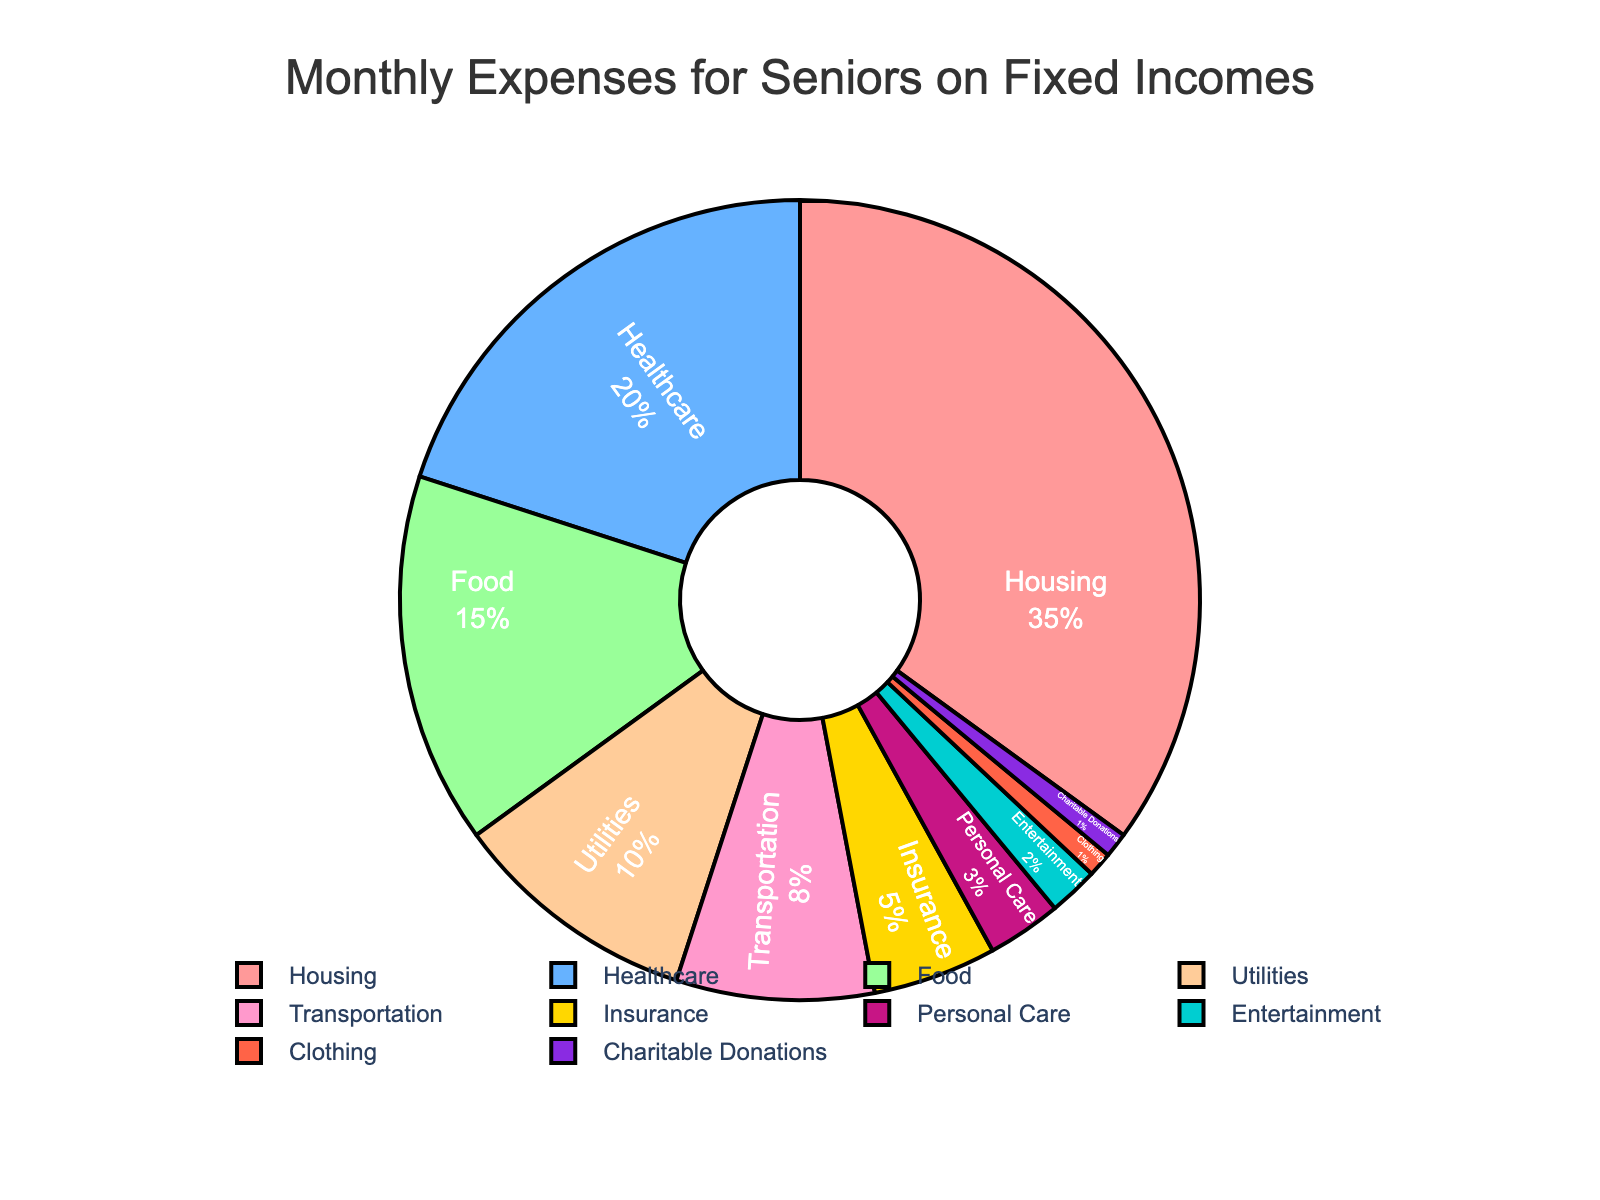Which category has the highest percentage allocation for monthly expenses? According to the pie chart, Housing has the largest slice, which indicates that it has the highest percentage allocation.
Answer: Housing What percentage of monthly expenses is spent on Healthcare and Transportation combined? The pie chart shows that Healthcare accounts for 20% and Transportation accounts for 8% of the monthly expenses. Adding these two gives 20% + 8% = 28%.
Answer: 28% Is the allocation for Food greater than for Utilities? Referring to the pie chart, Food accounts for 15% of expenses whereas Utilities account for 10%. Therefore, the allocation for Food is greater.
Answer: Yes How does the allocation for Entertainment compare to that for Charitable Donations? The pie chart shows that Entertainment takes up 2% and Charitable Donations take up 1%. Therefore, Entertainment has a higher allocation than Charitable Donations.
Answer: Entertainment has a higher allocation What is the total percentage allocated to Insurance and Personal Care? The pie chart shows that Insurance accounts for 5% and Personal Care accounts for 3%. Adding these together results in 5% + 3% = 8%.
Answer: 8% Which category represents the smallest allocation of monthly expenses? According to the pie chart, Clothing and Charitable Donations each account for 1%, which are the smallest allocations in the chart.
Answer: Clothing and Charitable Donations What is the combined percentage of the three largest expense categories? The three largest expense categories are Housing (35%), Healthcare (20%), and Food (15%). Adding these together gives 35% + 20% + 15% = 70%.
Answer: 70% Is Clothing or Personal Care assigned a higher percentage of the budget? The pie chart shows that Personal Care accounts for 3% of the budget, while Clothing accounts for 1%. Thus, Personal Care has a higher percentage allocation.
Answer: Personal Care 